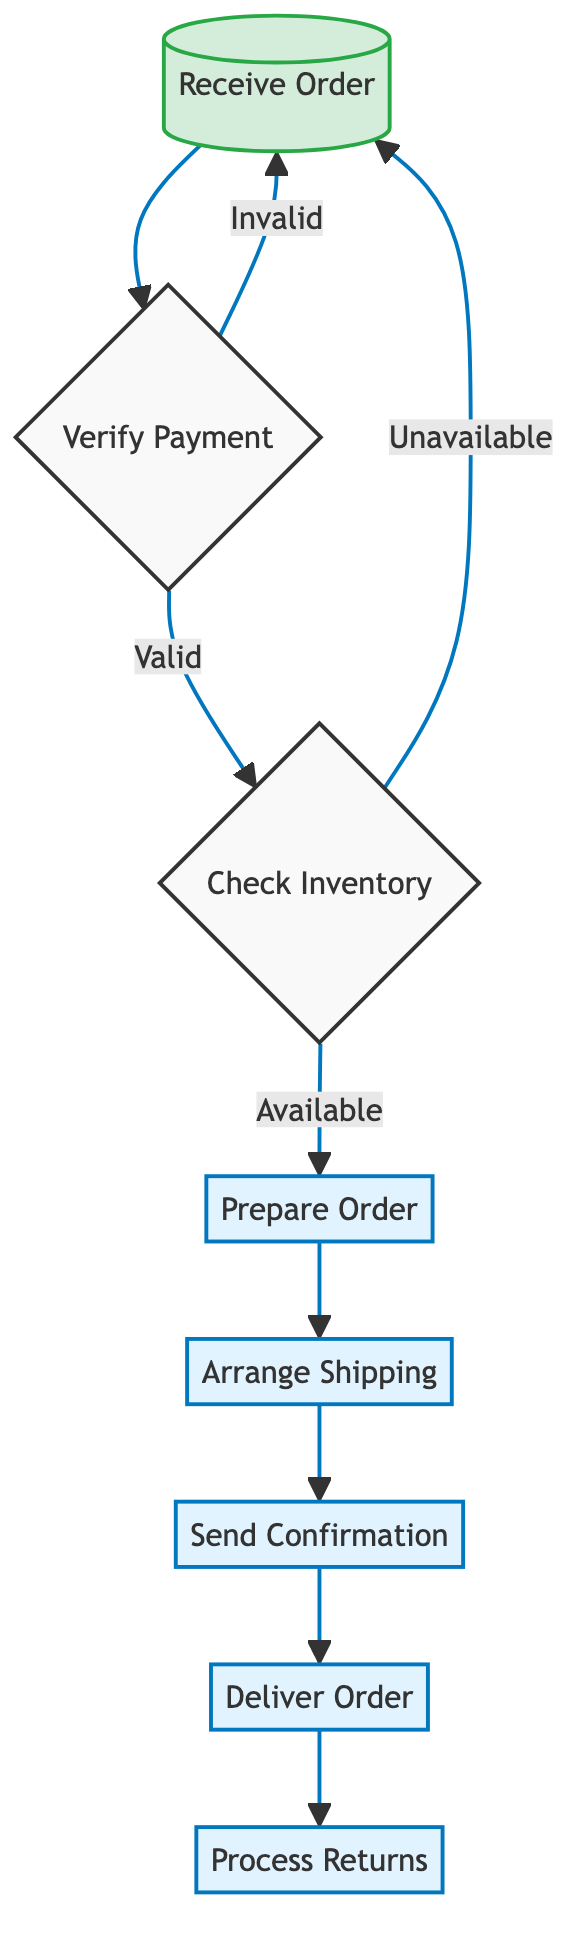What is the first step in the customer order processing workflow? The first step, as indicated in the diagram, is "Receive Order," which indicates the initiation of the workflow when the customer submits an order.
Answer: Receive Order How many processes are involved in the workflow? The workflow consists of seven distinct processes which are: Verify Payment, Check Inventory, Prepare Order, Arrange Shipping, Send Confirmation, Deliver Order, and Process Returns.
Answer: Seven What happens if the payment is invalid? If the payment is determined to be invalid, the flow indicates a loop back to the "Receive Order" step, signifying that the order process cannot continue until the payment is verified.
Answer: Receive Order What is the relationship between "Check Inventory" and "Prepare Order"? The "Check Inventory" step leads to the "Prepare Order" step only if the inventory is available, indicating that product availability is a prerequisite for order preparation.
Answer: Available After delivery, what process follows in the workflow? Once the "Deliver Order" process is completed, the next node in the workflow is "Process Returns," which handles any potential returns from the customer.
Answer: Process Returns How many decision points are in the workflow? There are two decision points in the workflow: one after "Verify Payment" (valid or invalid) and another after "Check Inventory" (available or unavailable), leading to a total of two decision points.
Answer: Two What is sent to the customer after arranging shipping? Following the "Arrange Shipping" process, the next step in the workflow is to "Send Confirmation," where the customer is informed with order confirmation and tracking information.
Answer: Send Confirmation If the inventory is unavailable, where does the process lead? If the inventory check shows that products are unavailable, the workflow indicates it returns to the "Receive Order" step, prompting the customer to submit the order again.
Answer: Receive Order What is the last step in the customer order processing workflow? The final step in the workflow is "Process Returns," which takes place after fulfilling the delivery of the order, managing any returned products.
Answer: Process Returns 